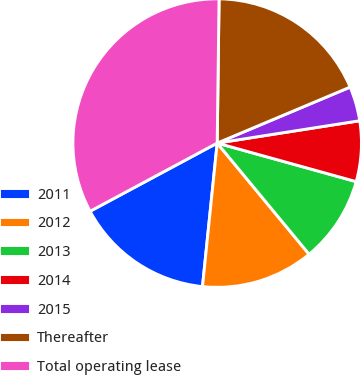<chart> <loc_0><loc_0><loc_500><loc_500><pie_chart><fcel>2011<fcel>2012<fcel>2013<fcel>2014<fcel>2015<fcel>Thereafter<fcel>Total operating lease<nl><fcel>15.54%<fcel>12.62%<fcel>9.7%<fcel>6.78%<fcel>3.87%<fcel>18.45%<fcel>33.04%<nl></chart> 